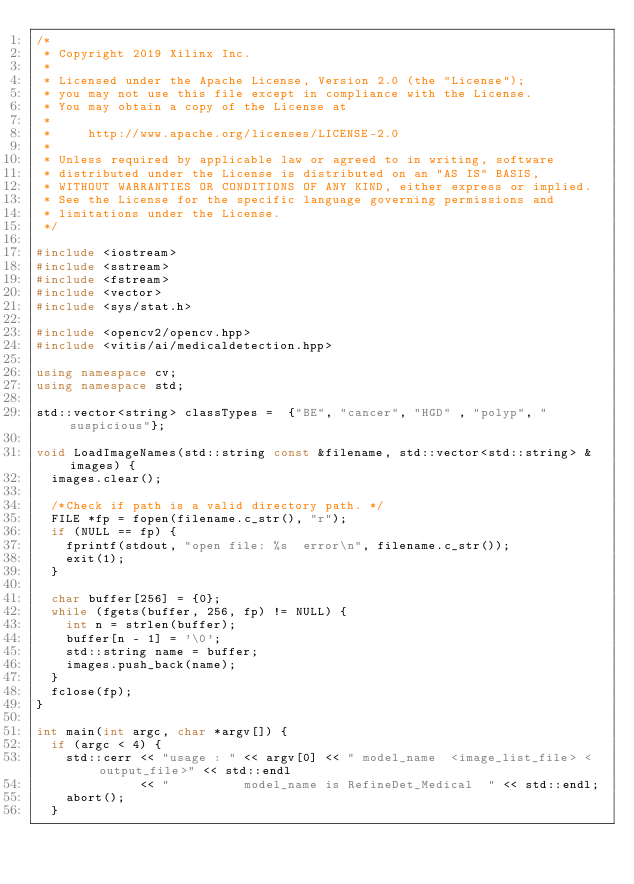Convert code to text. <code><loc_0><loc_0><loc_500><loc_500><_C++_>/*
 * Copyright 2019 Xilinx Inc.
 *
 * Licensed under the Apache License, Version 2.0 (the "License");
 * you may not use this file except in compliance with the License.
 * You may obtain a copy of the License at
 *
 *     http://www.apache.org/licenses/LICENSE-2.0
 *
 * Unless required by applicable law or agreed to in writing, software
 * distributed under the License is distributed on an "AS IS" BASIS,
 * WITHOUT WARRANTIES OR CONDITIONS OF ANY KIND, either express or implied.
 * See the License for the specific language governing permissions and
 * limitations under the License.
 */

#include <iostream>
#include <sstream>
#include <fstream>
#include <vector>
#include <sys/stat.h>

#include <opencv2/opencv.hpp>
#include <vitis/ai/medicaldetection.hpp>

using namespace cv;
using namespace std;

std::vector<string> classTypes =  {"BE", "cancer", "HGD" , "polyp", "suspicious"};

void LoadImageNames(std::string const &filename, std::vector<std::string> &images) {
  images.clear();

  /*Check if path is a valid directory path. */
  FILE *fp = fopen(filename.c_str(), "r");
  if (NULL == fp) {
    fprintf(stdout, "open file: %s  error\n", filename.c_str());
    exit(1);
  }

  char buffer[256] = {0};
  while (fgets(buffer, 256, fp) != NULL) {
    int n = strlen(buffer);
    buffer[n - 1] = '\0';
    std::string name = buffer;
    images.push_back(name);
  }
  fclose(fp);
}

int main(int argc, char *argv[]) {
  if (argc < 4) {
    std::cerr << "usage : " << argv[0] << " model_name  <image_list_file> <output_file>" << std::endl
              << "          model_name is RefineDet_Medical  " << std::endl;
    abort();
  }
</code> 